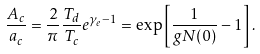Convert formula to latex. <formula><loc_0><loc_0><loc_500><loc_500>\frac { A _ { c } } { a _ { c } } = \frac { 2 } { \pi } \frac { T _ { d } } { T _ { c } } e ^ { \gamma _ { e } - 1 } = \exp \left [ \frac { 1 } { g N ( 0 ) } - 1 \right ] .</formula> 